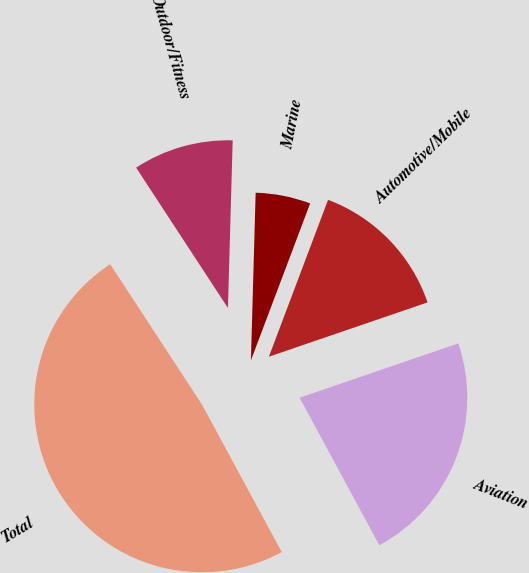Convert chart. <chart><loc_0><loc_0><loc_500><loc_500><pie_chart><fcel>Outdoor/Fitness<fcel>Marine<fcel>Automotive/Mobile<fcel>Aviation<fcel>Total<nl><fcel>9.67%<fcel>5.29%<fcel>14.01%<fcel>22.36%<fcel>48.67%<nl></chart> 